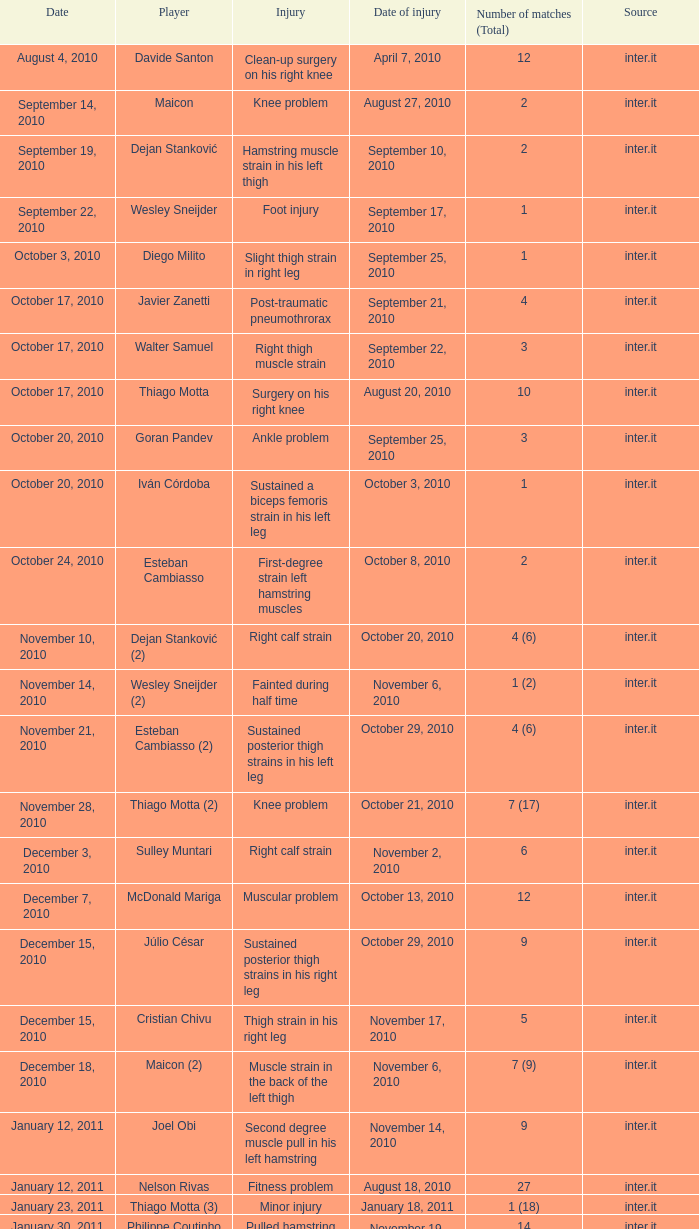On how many occasions did the date october 3, 2010, occur? 1.0. 